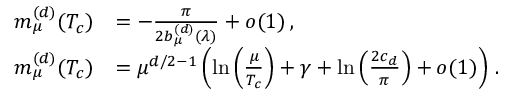<formula> <loc_0><loc_0><loc_500><loc_500>\begin{array} { r l } { m _ { \mu } ^ { ( d ) } ( T _ { c } ) } & { = - \frac { \pi } { 2 b _ { \mu } ^ { ( d ) } ( \lambda ) } + o ( 1 ) \, , } \\ { m _ { \mu } ^ { ( d ) } ( T _ { c } ) } & { = \mu ^ { d / 2 - 1 } \left ( \ln \left ( \frac { \mu } { T _ { c } } \right ) + \gamma + \ln \left ( \frac { 2 c _ { d } } { \pi } \right ) + o ( 1 ) \right ) \, . } \end{array}</formula> 